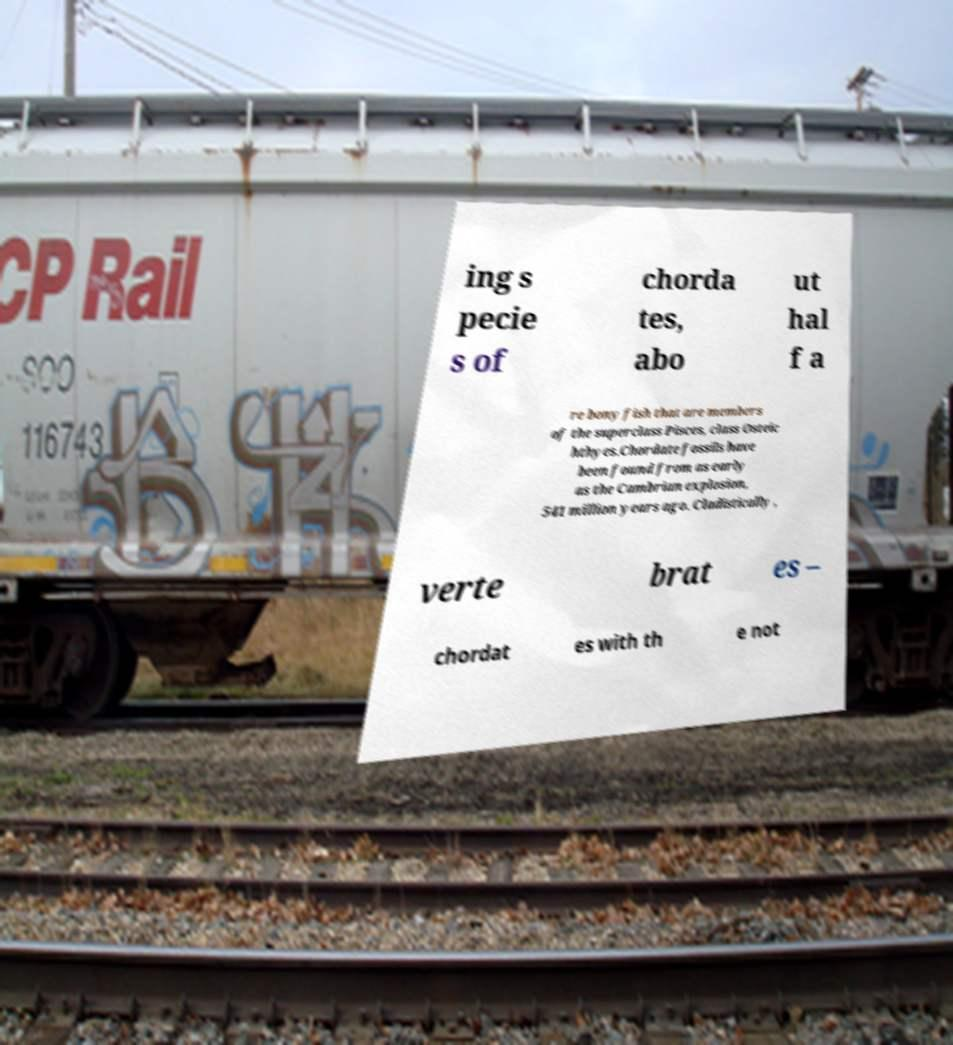What messages or text are displayed in this image? I need them in a readable, typed format. ing s pecie s of chorda tes, abo ut hal f a re bony fish that are members of the superclass Pisces, class Osteic hthyes.Chordate fossils have been found from as early as the Cambrian explosion, 541 million years ago. Cladistically , verte brat es – chordat es with th e not 